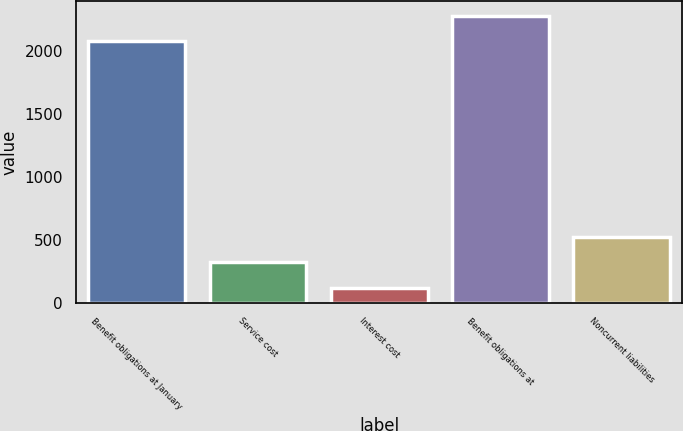Convert chart. <chart><loc_0><loc_0><loc_500><loc_500><bar_chart><fcel>Benefit obligations at January<fcel>Service cost<fcel>Interest cost<fcel>Benefit obligations at<fcel>Noncurrent liabilities<nl><fcel>2077<fcel>325.9<fcel>124<fcel>2278.9<fcel>527.8<nl></chart> 